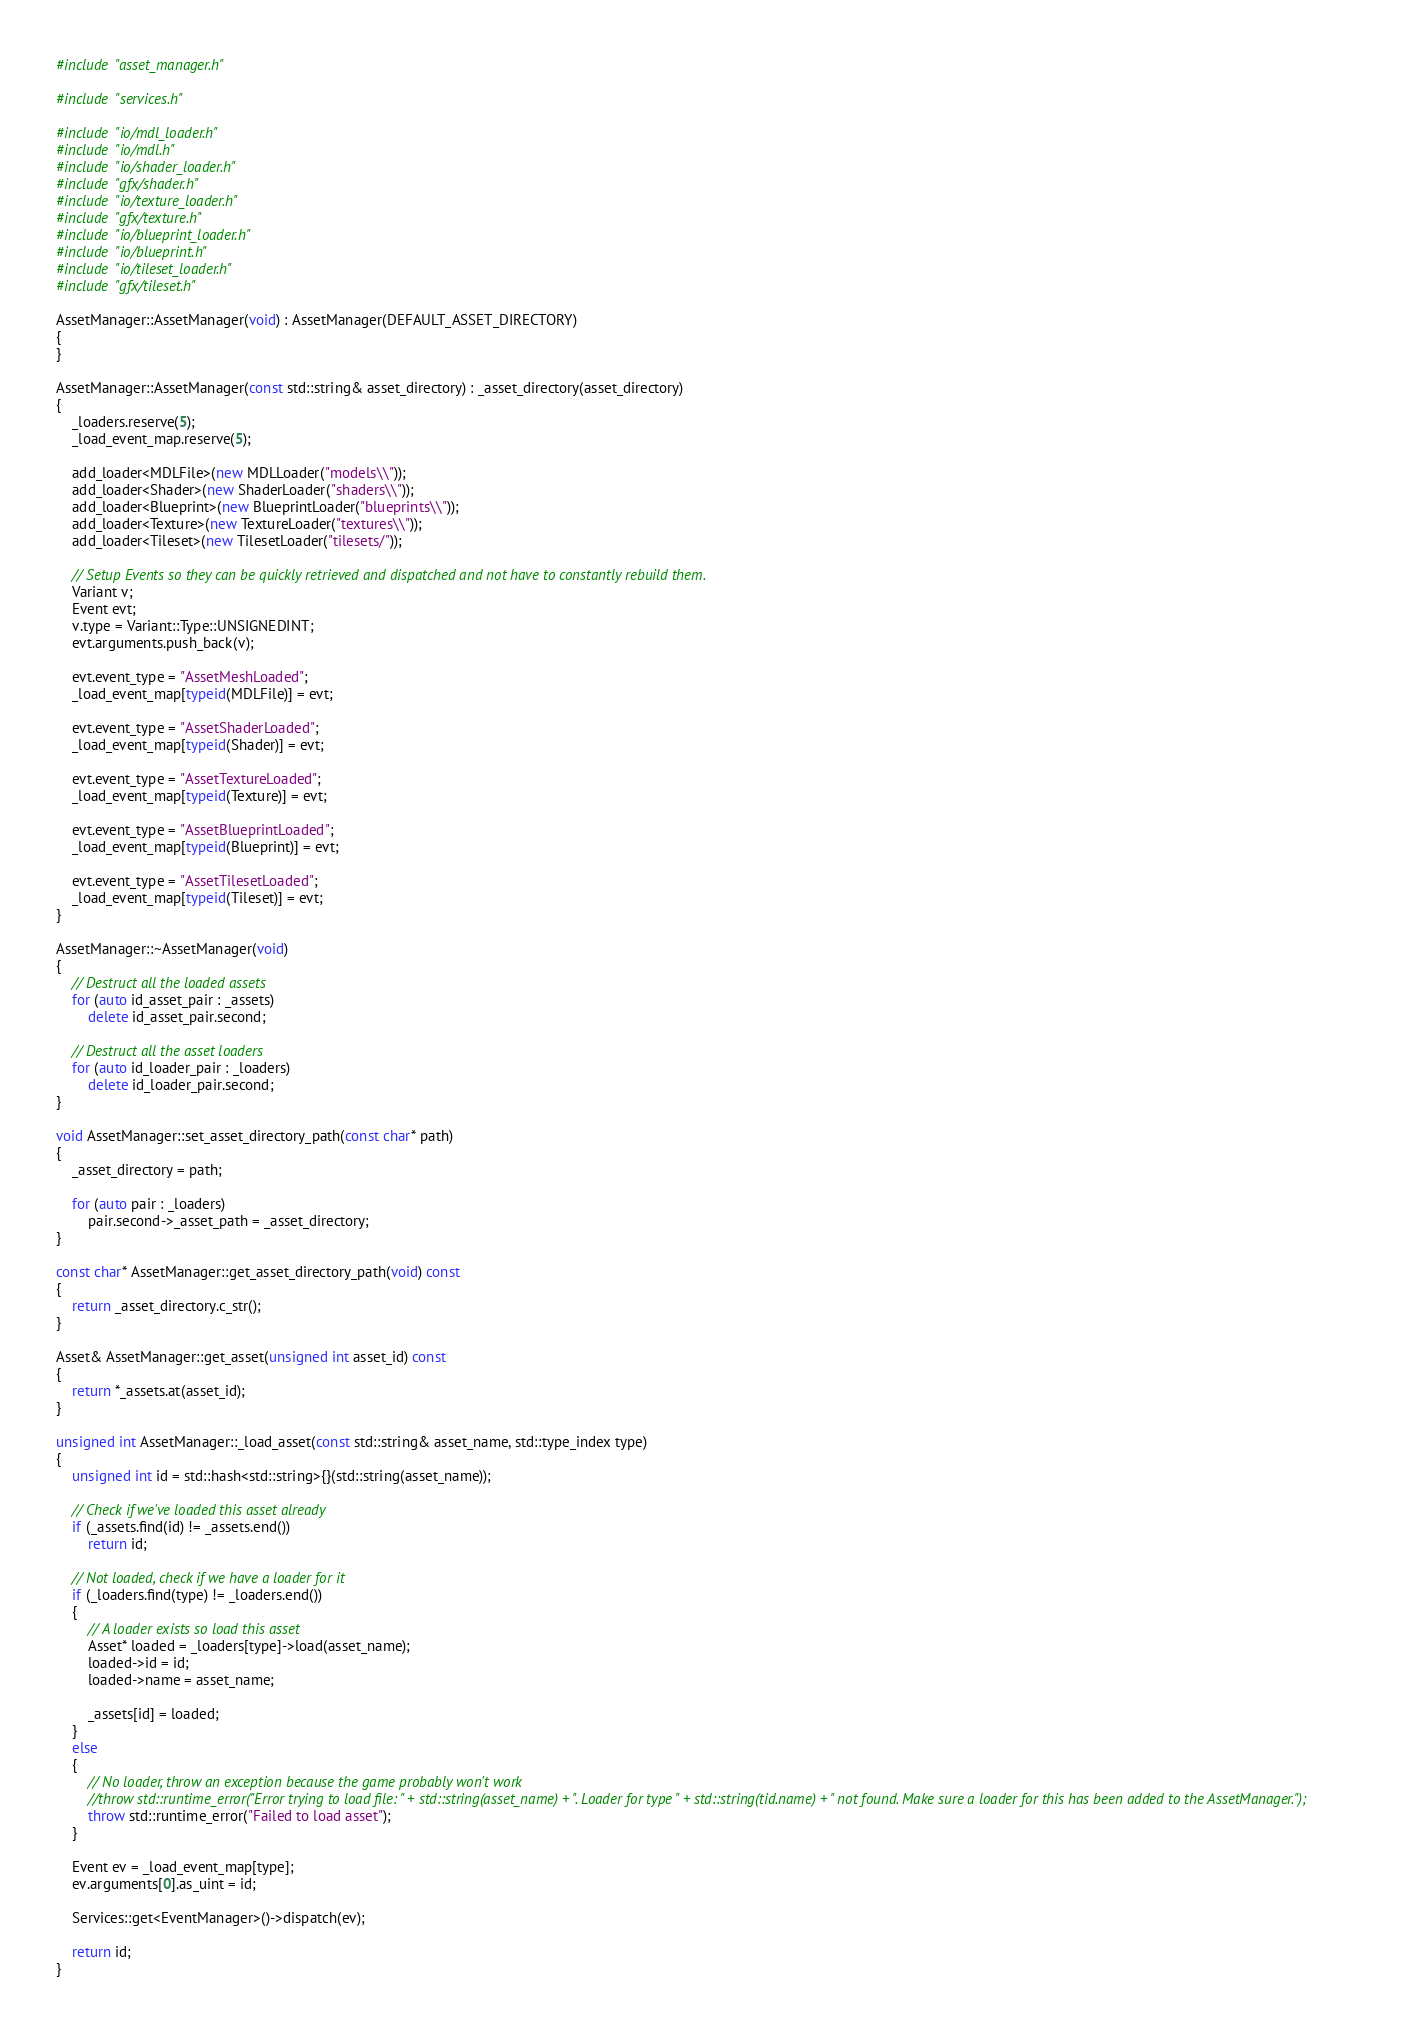<code> <loc_0><loc_0><loc_500><loc_500><_C++_>#include "asset_manager.h"

#include "services.h"

#include "io/mdl_loader.h"
#include "io/mdl.h"
#include "io/shader_loader.h"
#include "gfx/shader.h"
#include "io/texture_loader.h"
#include "gfx/texture.h"
#include "io/blueprint_loader.h"
#include "io/blueprint.h"
#include "io/tileset_loader.h"
#include "gfx/tileset.h"

AssetManager::AssetManager(void) : AssetManager(DEFAULT_ASSET_DIRECTORY)
{
}

AssetManager::AssetManager(const std::string& asset_directory) : _asset_directory(asset_directory)
{
	_loaders.reserve(5);
	_load_event_map.reserve(5);

	add_loader<MDLFile>(new MDLLoader("models\\"));
	add_loader<Shader>(new ShaderLoader("shaders\\"));
	add_loader<Blueprint>(new BlueprintLoader("blueprints\\"));
	add_loader<Texture>(new TextureLoader("textures\\"));
	add_loader<Tileset>(new TilesetLoader("tilesets/"));

	// Setup Events so they can be quickly retrieved and dispatched and not have to constantly rebuild them.
	Variant v;
	Event evt;
	v.type = Variant::Type::UNSIGNEDINT;
	evt.arguments.push_back(v);

	evt.event_type = "AssetMeshLoaded";
	_load_event_map[typeid(MDLFile)] = evt;

	evt.event_type = "AssetShaderLoaded";
	_load_event_map[typeid(Shader)] = evt;

	evt.event_type = "AssetTextureLoaded";
	_load_event_map[typeid(Texture)] = evt;

	evt.event_type = "AssetBlueprintLoaded";
	_load_event_map[typeid(Blueprint)] = evt;

	evt.event_type = "AssetTilesetLoaded";
	_load_event_map[typeid(Tileset)] = evt;
}

AssetManager::~AssetManager(void)
{
	// Destruct all the loaded assets
	for (auto id_asset_pair : _assets)
		delete id_asset_pair.second;

	// Destruct all the asset loaders
	for (auto id_loader_pair : _loaders)
		delete id_loader_pair.second;
}

void AssetManager::set_asset_directory_path(const char* path)
{
	_asset_directory = path;

	for (auto pair : _loaders)
		pair.second->_asset_path = _asset_directory;
}

const char* AssetManager::get_asset_directory_path(void) const
{
	return _asset_directory.c_str();
}

Asset& AssetManager::get_asset(unsigned int asset_id) const
{
	return *_assets.at(asset_id);
}

unsigned int AssetManager::_load_asset(const std::string& asset_name, std::type_index type)
{
	unsigned int id = std::hash<std::string>{}(std::string(asset_name));

	// Check if we've loaded this asset already
	if (_assets.find(id) != _assets.end())
		return id;

	// Not loaded, check if we have a loader for it
	if (_loaders.find(type) != _loaders.end())
	{
		// A loader exists so load this asset
		Asset* loaded = _loaders[type]->load(asset_name);
		loaded->id = id;
		loaded->name = asset_name;

		_assets[id] = loaded;
	}
	else
	{
		// No loader, throw an exception because the game probably won't work
		//throw std::runtime_error("Error trying to load file: " + std::string(asset_name) + ". Loader for type " + std::string(tid.name) + " not found. Make sure a loader for this has been added to the AssetManager.");
		throw std::runtime_error("Failed to load asset");
	}

	Event ev = _load_event_map[type];
	ev.arguments[0].as_uint = id;

	Services::get<EventManager>()->dispatch(ev);

	return id;
}</code> 